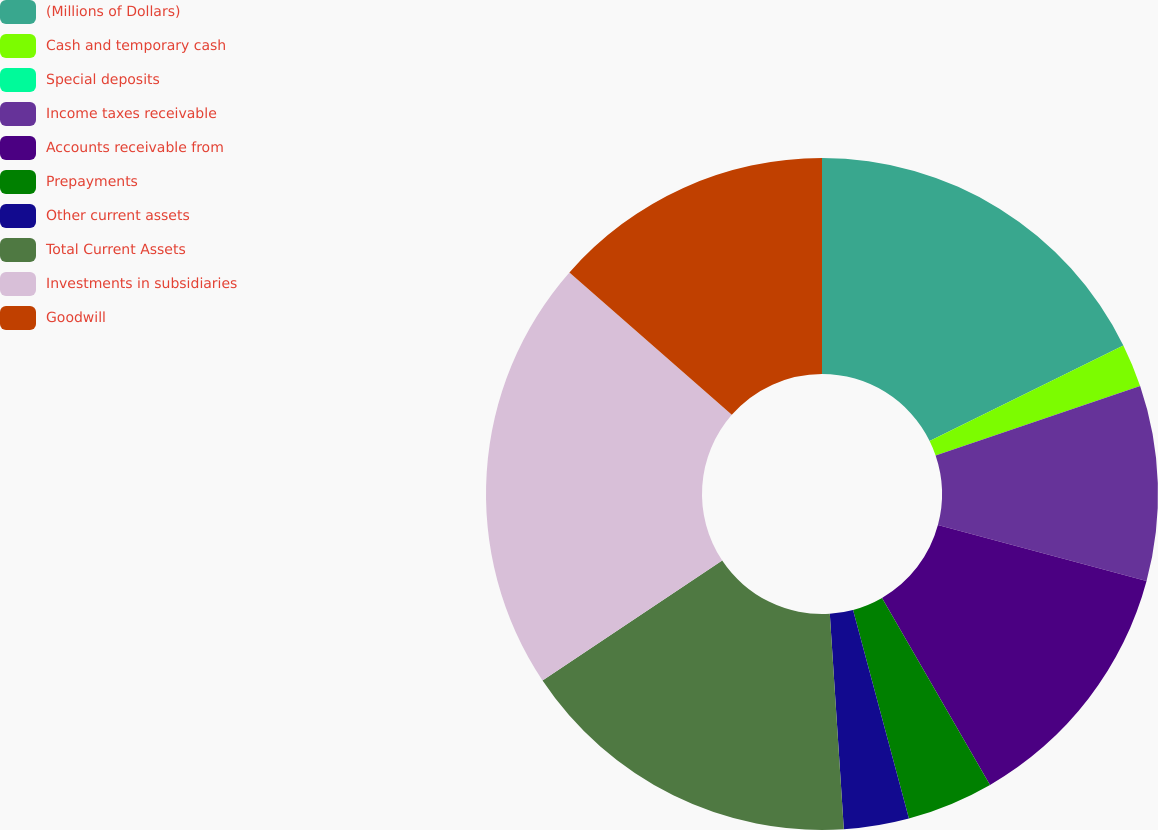Convert chart to OTSL. <chart><loc_0><loc_0><loc_500><loc_500><pie_chart><fcel>(Millions of Dollars)<fcel>Cash and temporary cash<fcel>Special deposits<fcel>Income taxes receivable<fcel>Accounts receivable from<fcel>Prepayments<fcel>Other current assets<fcel>Total Current Assets<fcel>Investments in subsidiaries<fcel>Goodwill<nl><fcel>17.71%<fcel>2.08%<fcel>0.0%<fcel>9.38%<fcel>12.5%<fcel>4.17%<fcel>3.13%<fcel>16.67%<fcel>20.83%<fcel>13.54%<nl></chart> 